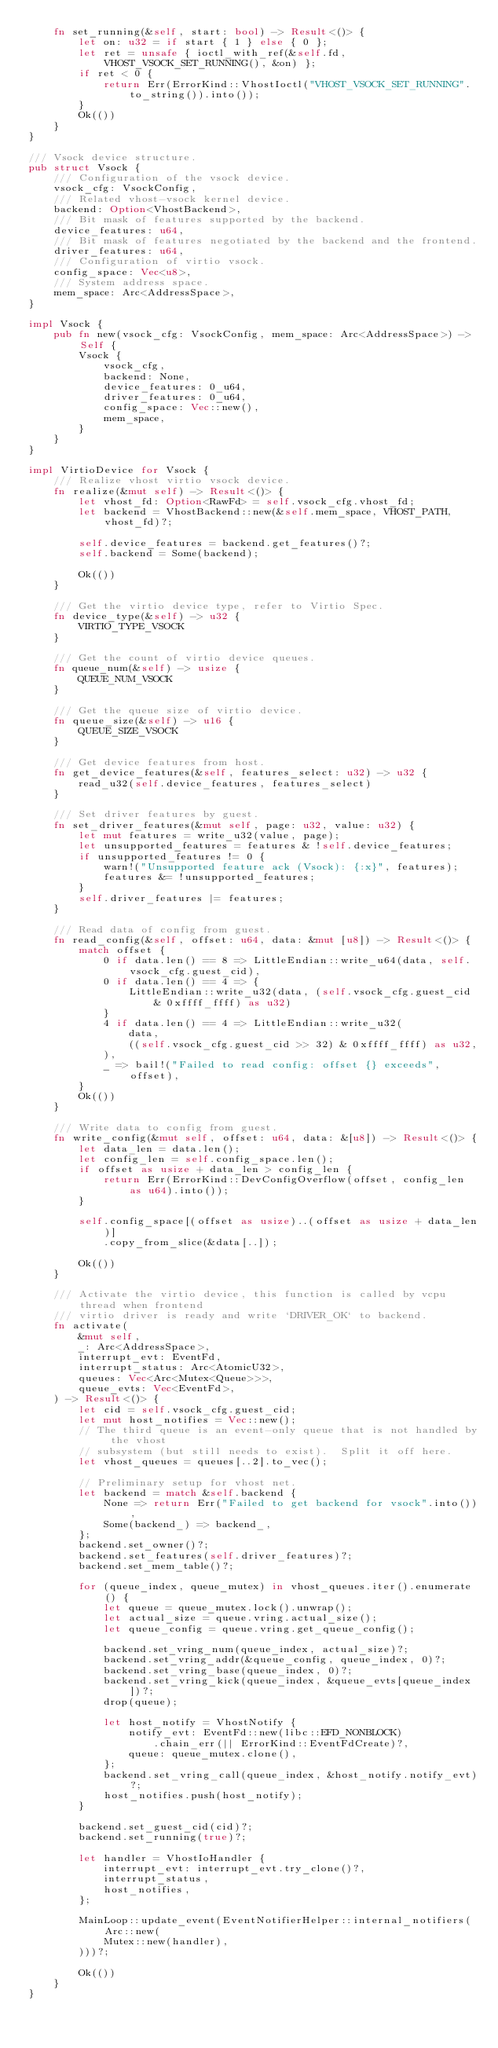Convert code to text. <code><loc_0><loc_0><loc_500><loc_500><_Rust_>    fn set_running(&self, start: bool) -> Result<()> {
        let on: u32 = if start { 1 } else { 0 };
        let ret = unsafe { ioctl_with_ref(&self.fd, VHOST_VSOCK_SET_RUNNING(), &on) };
        if ret < 0 {
            return Err(ErrorKind::VhostIoctl("VHOST_VSOCK_SET_RUNNING".to_string()).into());
        }
        Ok(())
    }
}

/// Vsock device structure.
pub struct Vsock {
    /// Configuration of the vsock device.
    vsock_cfg: VsockConfig,
    /// Related vhost-vsock kernel device.
    backend: Option<VhostBackend>,
    /// Bit mask of features supported by the backend.
    device_features: u64,
    /// Bit mask of features negotiated by the backend and the frontend.
    driver_features: u64,
    /// Configuration of virtio vsock.
    config_space: Vec<u8>,
    /// System address space.
    mem_space: Arc<AddressSpace>,
}

impl Vsock {
    pub fn new(vsock_cfg: VsockConfig, mem_space: Arc<AddressSpace>) -> Self {
        Vsock {
            vsock_cfg,
            backend: None,
            device_features: 0_u64,
            driver_features: 0_u64,
            config_space: Vec::new(),
            mem_space,
        }
    }
}

impl VirtioDevice for Vsock {
    /// Realize vhost virtio vsock device.
    fn realize(&mut self) -> Result<()> {
        let vhost_fd: Option<RawFd> = self.vsock_cfg.vhost_fd;
        let backend = VhostBackend::new(&self.mem_space, VHOST_PATH, vhost_fd)?;

        self.device_features = backend.get_features()?;
        self.backend = Some(backend);

        Ok(())
    }

    /// Get the virtio device type, refer to Virtio Spec.
    fn device_type(&self) -> u32 {
        VIRTIO_TYPE_VSOCK
    }

    /// Get the count of virtio device queues.
    fn queue_num(&self) -> usize {
        QUEUE_NUM_VSOCK
    }

    /// Get the queue size of virtio device.
    fn queue_size(&self) -> u16 {
        QUEUE_SIZE_VSOCK
    }

    /// Get device features from host.
    fn get_device_features(&self, features_select: u32) -> u32 {
        read_u32(self.device_features, features_select)
    }

    /// Set driver features by guest.
    fn set_driver_features(&mut self, page: u32, value: u32) {
        let mut features = write_u32(value, page);
        let unsupported_features = features & !self.device_features;
        if unsupported_features != 0 {
            warn!("Unsupported feature ack (Vsock): {:x}", features);
            features &= !unsupported_features;
        }
        self.driver_features |= features;
    }

    /// Read data of config from guest.
    fn read_config(&self, offset: u64, data: &mut [u8]) -> Result<()> {
        match offset {
            0 if data.len() == 8 => LittleEndian::write_u64(data, self.vsock_cfg.guest_cid),
            0 if data.len() == 4 => {
                LittleEndian::write_u32(data, (self.vsock_cfg.guest_cid & 0xffff_ffff) as u32)
            }
            4 if data.len() == 4 => LittleEndian::write_u32(
                data,
                ((self.vsock_cfg.guest_cid >> 32) & 0xffff_ffff) as u32,
            ),
            _ => bail!("Failed to read config: offset {} exceeds", offset),
        }
        Ok(())
    }

    /// Write data to config from guest.
    fn write_config(&mut self, offset: u64, data: &[u8]) -> Result<()> {
        let data_len = data.len();
        let config_len = self.config_space.len();
        if offset as usize + data_len > config_len {
            return Err(ErrorKind::DevConfigOverflow(offset, config_len as u64).into());
        }

        self.config_space[(offset as usize)..(offset as usize + data_len)]
            .copy_from_slice(&data[..]);

        Ok(())
    }

    /// Activate the virtio device, this function is called by vcpu thread when frontend
    /// virtio driver is ready and write `DRIVER_OK` to backend.
    fn activate(
        &mut self,
        _: Arc<AddressSpace>,
        interrupt_evt: EventFd,
        interrupt_status: Arc<AtomicU32>,
        queues: Vec<Arc<Mutex<Queue>>>,
        queue_evts: Vec<EventFd>,
    ) -> Result<()> {
        let cid = self.vsock_cfg.guest_cid;
        let mut host_notifies = Vec::new();
        // The third queue is an event-only queue that is not handled by the vhost
        // subsystem (but still needs to exist).  Split it off here.
        let vhost_queues = queues[..2].to_vec();

        // Preliminary setup for vhost net.
        let backend = match &self.backend {
            None => return Err("Failed to get backend for vsock".into()),
            Some(backend_) => backend_,
        };
        backend.set_owner()?;
        backend.set_features(self.driver_features)?;
        backend.set_mem_table()?;

        for (queue_index, queue_mutex) in vhost_queues.iter().enumerate() {
            let queue = queue_mutex.lock().unwrap();
            let actual_size = queue.vring.actual_size();
            let queue_config = queue.vring.get_queue_config();

            backend.set_vring_num(queue_index, actual_size)?;
            backend.set_vring_addr(&queue_config, queue_index, 0)?;
            backend.set_vring_base(queue_index, 0)?;
            backend.set_vring_kick(queue_index, &queue_evts[queue_index])?;
            drop(queue);

            let host_notify = VhostNotify {
                notify_evt: EventFd::new(libc::EFD_NONBLOCK)
                    .chain_err(|| ErrorKind::EventFdCreate)?,
                queue: queue_mutex.clone(),
            };
            backend.set_vring_call(queue_index, &host_notify.notify_evt)?;
            host_notifies.push(host_notify);
        }

        backend.set_guest_cid(cid)?;
        backend.set_running(true)?;

        let handler = VhostIoHandler {
            interrupt_evt: interrupt_evt.try_clone()?,
            interrupt_status,
            host_notifies,
        };

        MainLoop::update_event(EventNotifierHelper::internal_notifiers(Arc::new(
            Mutex::new(handler),
        )))?;

        Ok(())
    }
}
</code> 